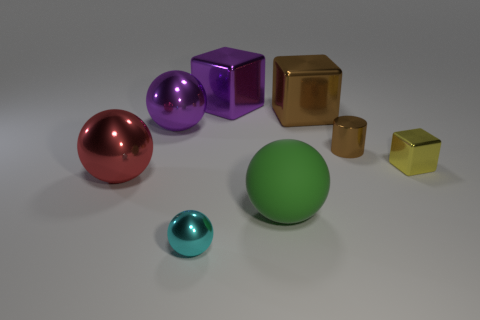Add 1 big purple things. How many objects exist? 9 Subtract all purple shiny balls. How many balls are left? 3 Subtract 2 balls. How many balls are left? 2 Subtract all green balls. How many balls are left? 3 Subtract all cubes. How many objects are left? 5 Add 1 big purple things. How many big purple things are left? 3 Add 8 tiny yellow balls. How many tiny yellow balls exist? 8 Subtract 1 brown cylinders. How many objects are left? 7 Subtract all green blocks. Subtract all cyan cylinders. How many blocks are left? 3 Subtract all large cylinders. Subtract all large metal objects. How many objects are left? 4 